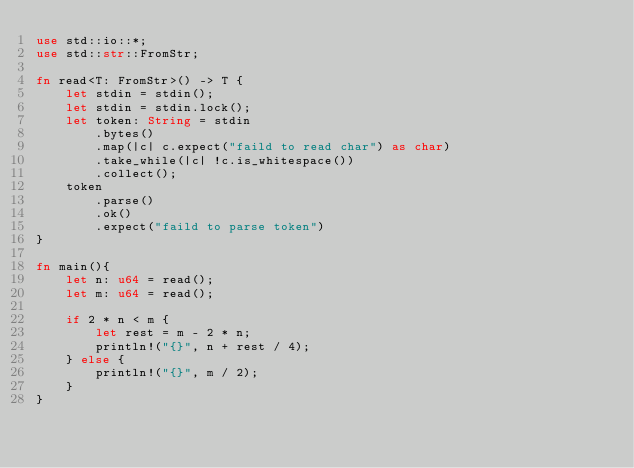Convert code to text. <code><loc_0><loc_0><loc_500><loc_500><_Rust_>use std::io::*;
use std::str::FromStr;

fn read<T: FromStr>() -> T {
    let stdin = stdin();
    let stdin = stdin.lock();
    let token: String = stdin
        .bytes()
        .map(|c| c.expect("faild to read char") as char)
        .take_while(|c| !c.is_whitespace())
        .collect();
    token
        .parse()
        .ok()
        .expect("faild to parse token")
}

fn main(){
    let n: u64 = read();
    let m: u64 = read();

    if 2 * n < m {
        let rest = m - 2 * n;
        println!("{}", n + rest / 4);
    } else {
        println!("{}", m / 2);
    }
}
</code> 